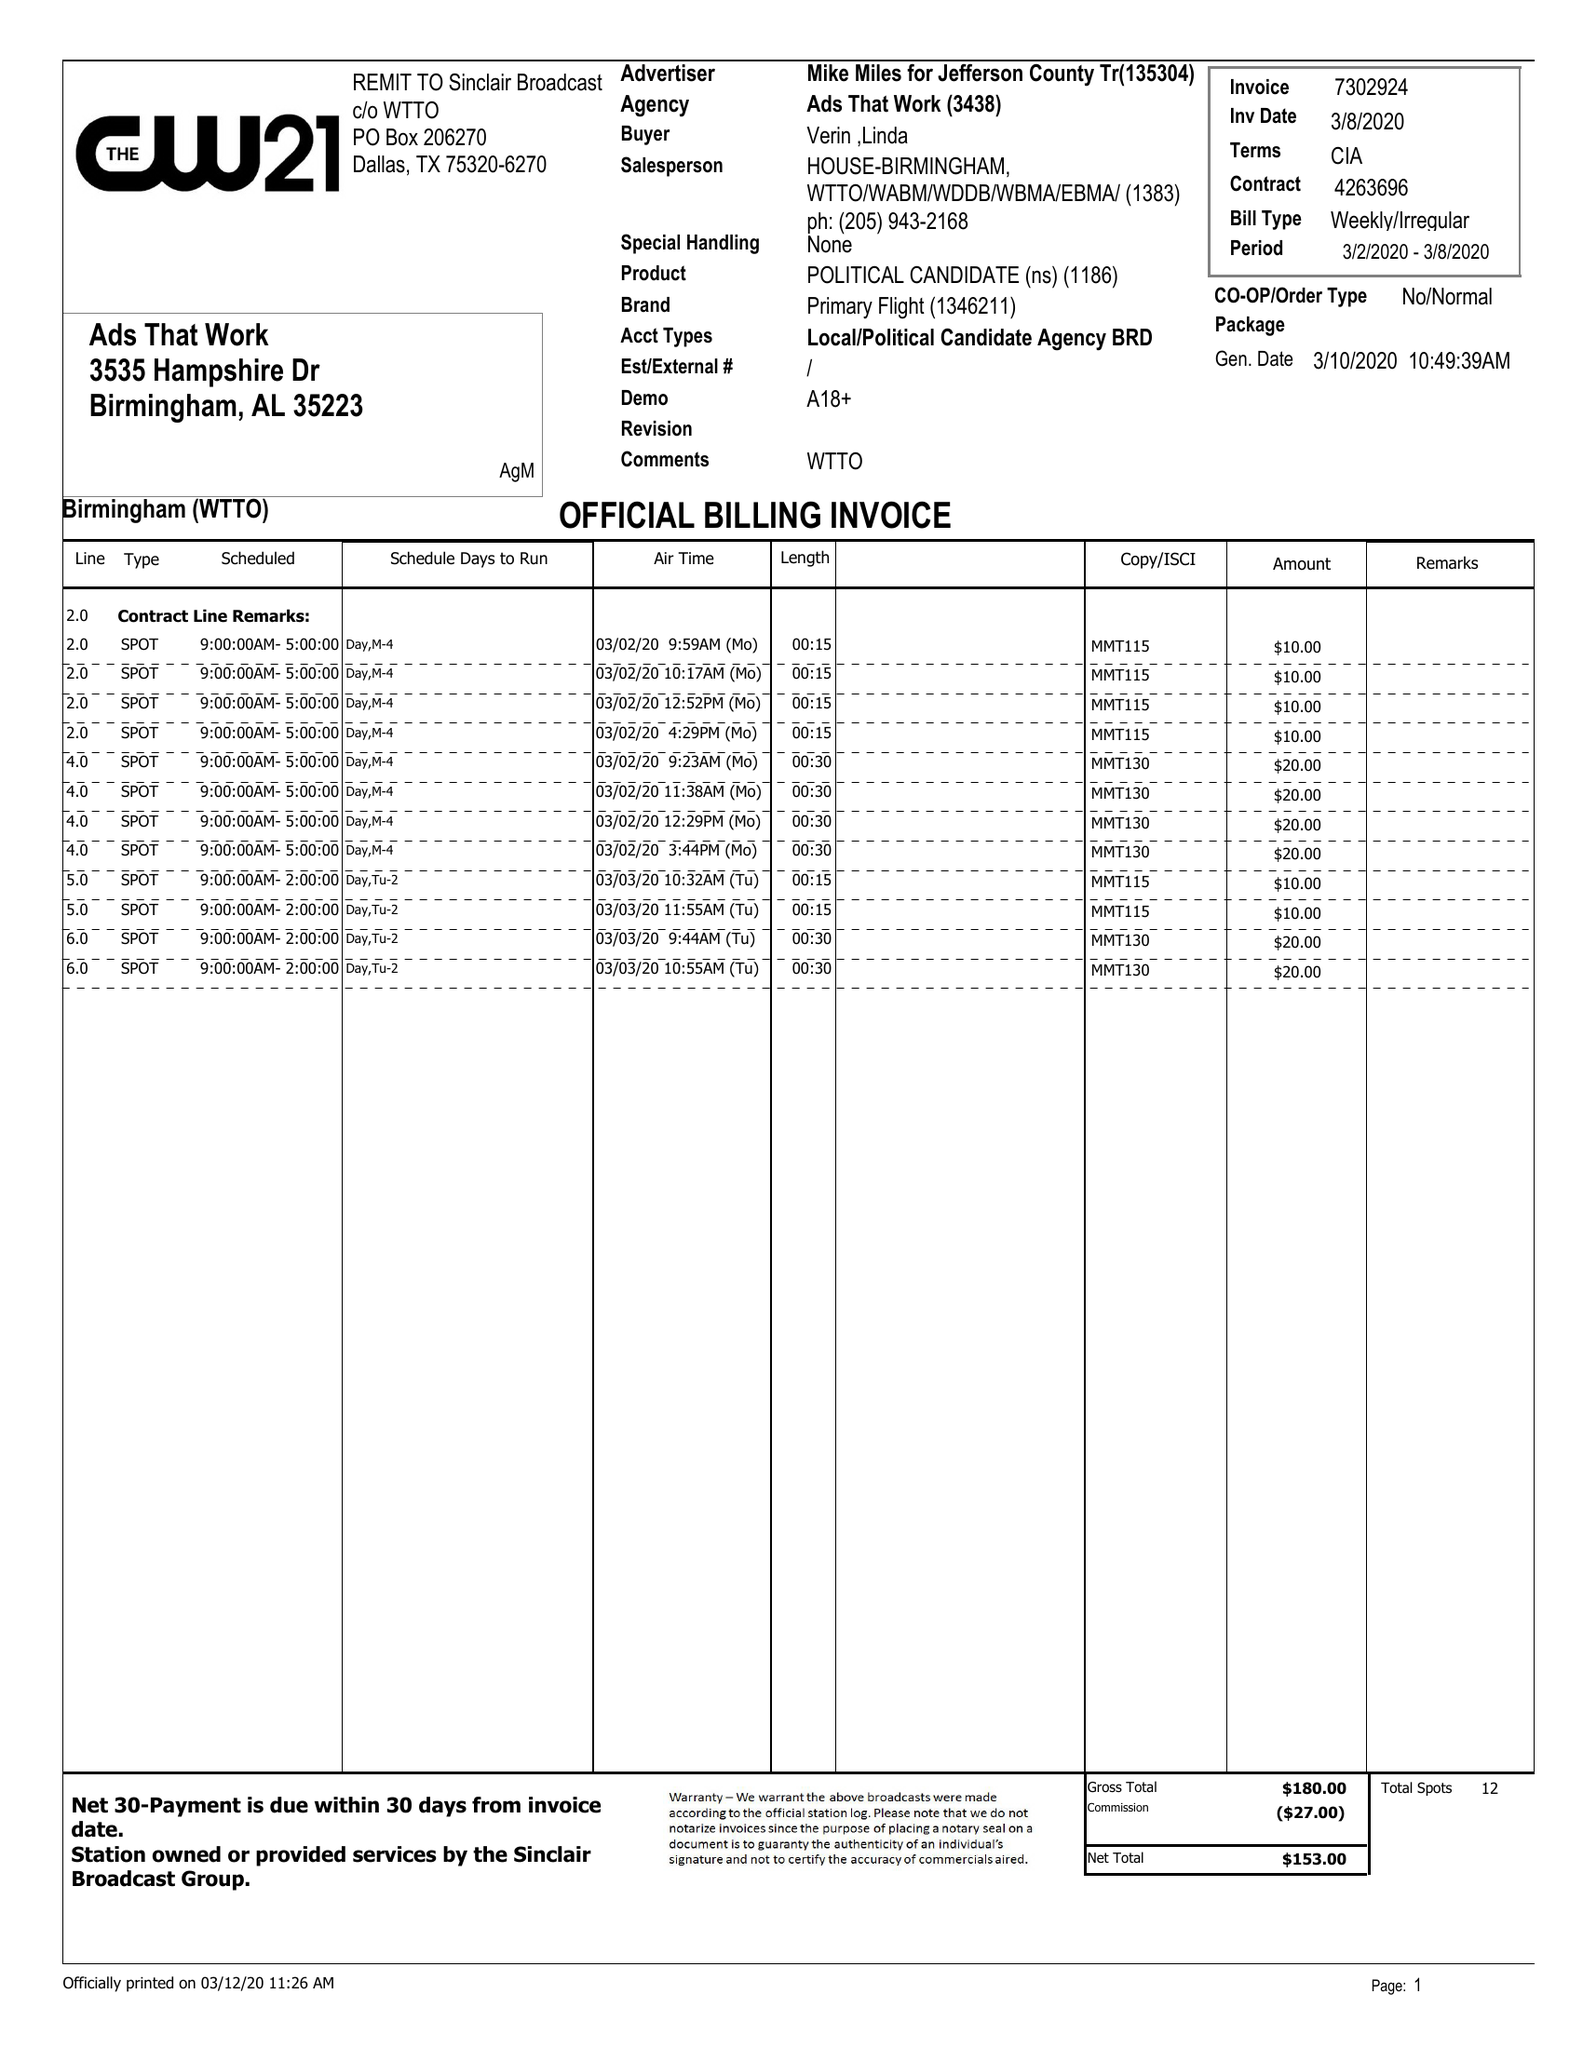What is the value for the gross_amount?
Answer the question using a single word or phrase. 180.00 